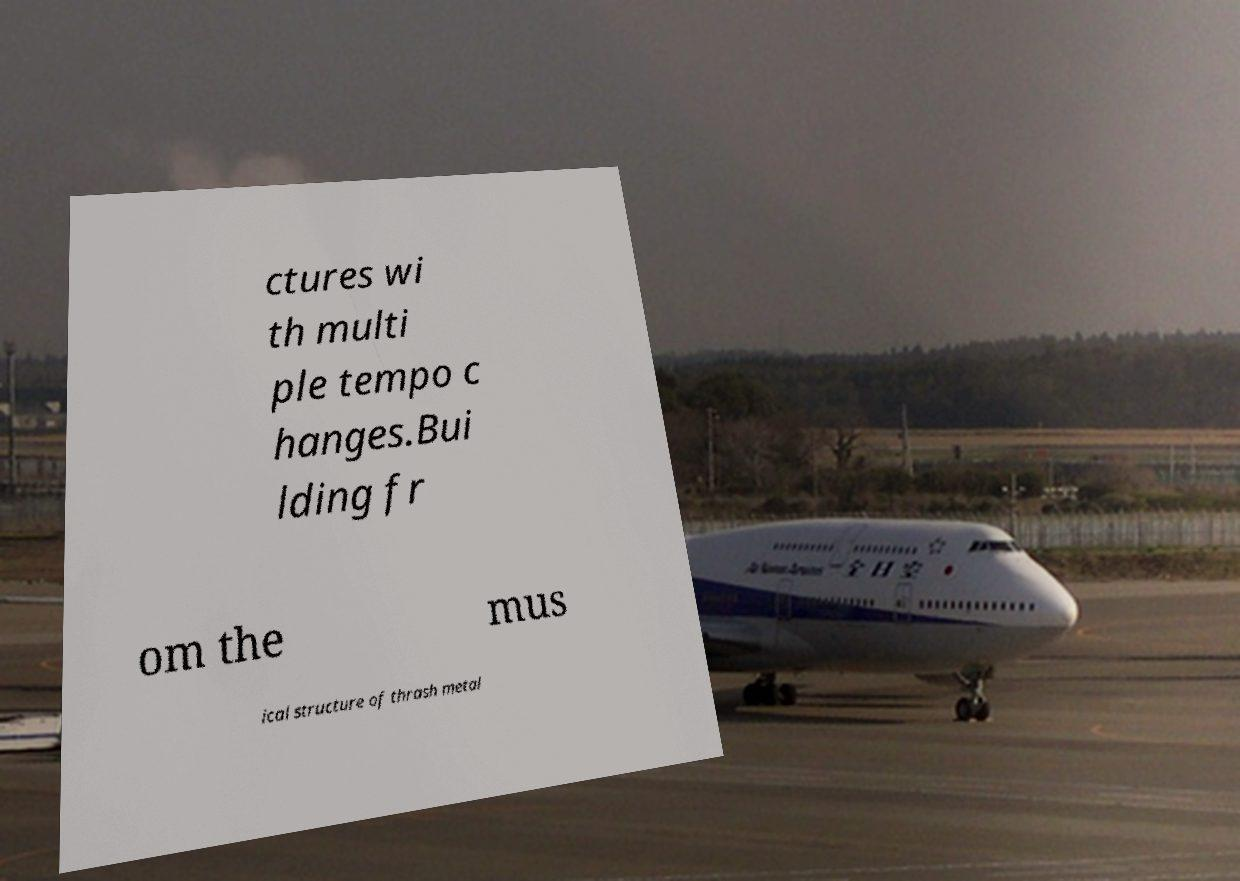Could you assist in decoding the text presented in this image and type it out clearly? ctures wi th multi ple tempo c hanges.Bui lding fr om the mus ical structure of thrash metal 